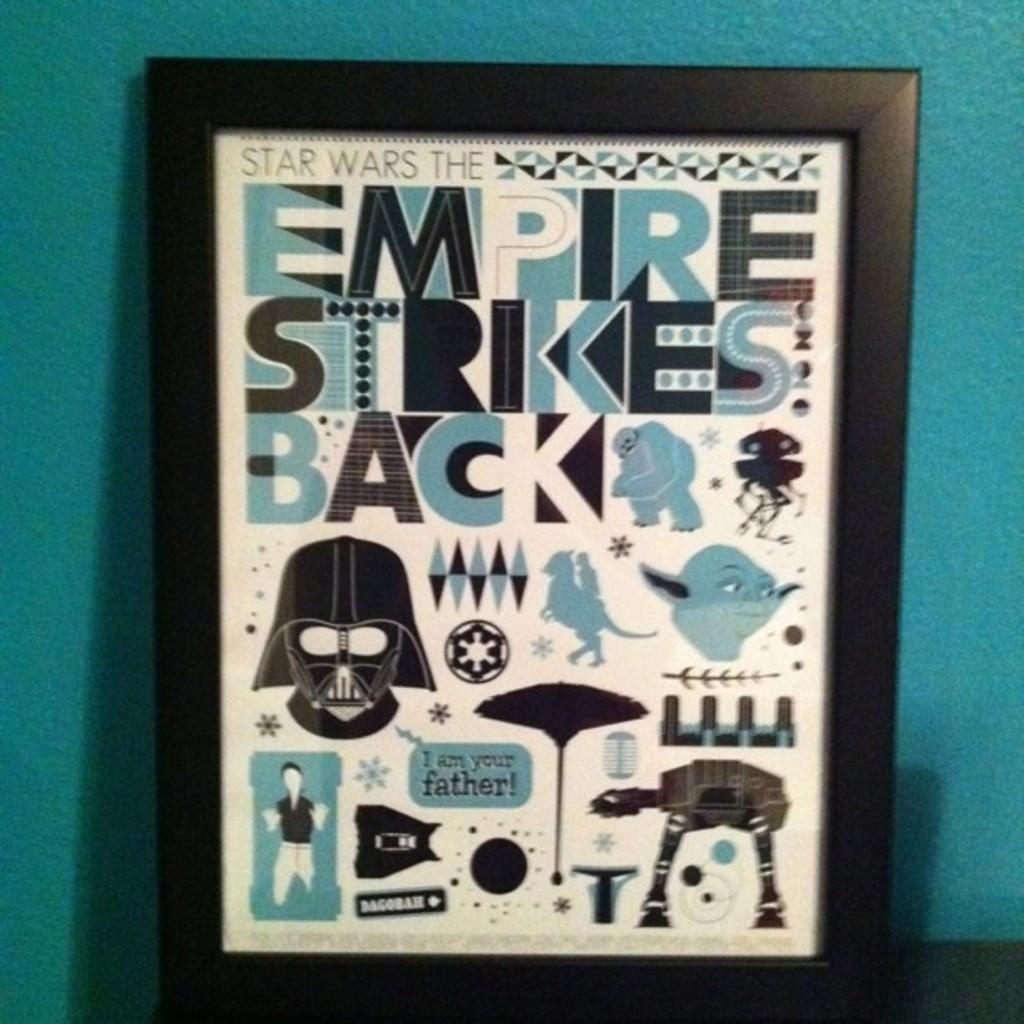What movie is this referencing?
Offer a terse response. Empire strikes back. 